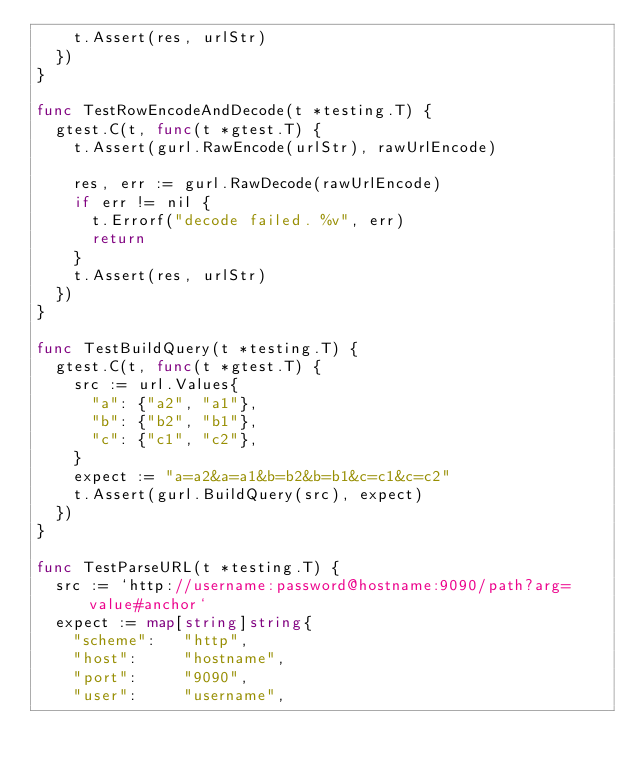Convert code to text. <code><loc_0><loc_0><loc_500><loc_500><_Go_>		t.Assert(res, urlStr)
	})
}

func TestRowEncodeAndDecode(t *testing.T) {
	gtest.C(t, func(t *gtest.T) {
		t.Assert(gurl.RawEncode(urlStr), rawUrlEncode)

		res, err := gurl.RawDecode(rawUrlEncode)
		if err != nil {
			t.Errorf("decode failed. %v", err)
			return
		}
		t.Assert(res, urlStr)
	})
}

func TestBuildQuery(t *testing.T) {
	gtest.C(t, func(t *gtest.T) {
		src := url.Values{
			"a": {"a2", "a1"},
			"b": {"b2", "b1"},
			"c": {"c1", "c2"},
		}
		expect := "a=a2&a=a1&b=b2&b=b1&c=c1&c=c2"
		t.Assert(gurl.BuildQuery(src), expect)
	})
}

func TestParseURL(t *testing.T) {
	src := `http://username:password@hostname:9090/path?arg=value#anchor`
	expect := map[string]string{
		"scheme":   "http",
		"host":     "hostname",
		"port":     "9090",
		"user":     "username",</code> 